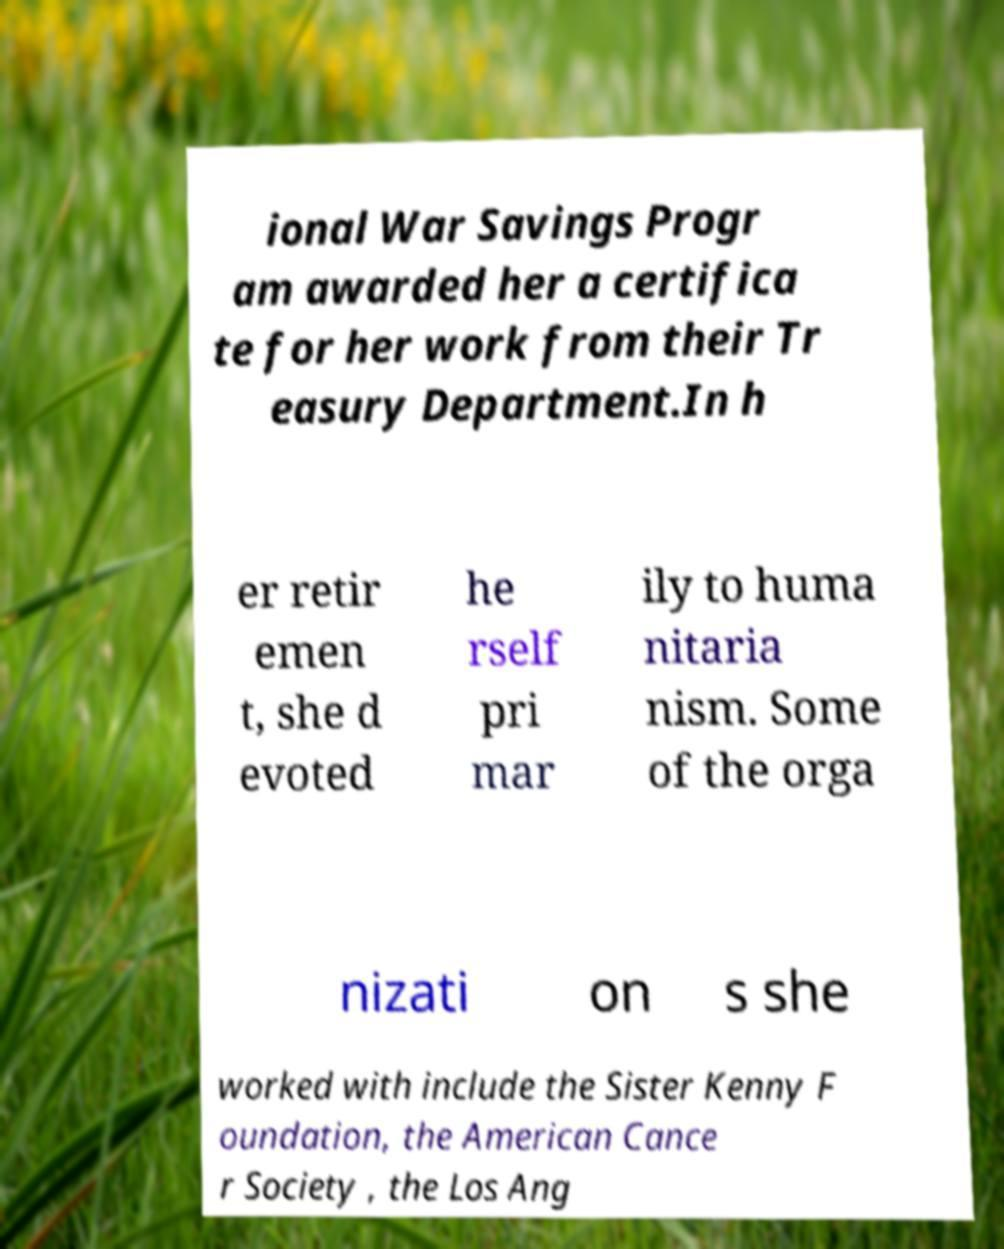I need the written content from this picture converted into text. Can you do that? ional War Savings Progr am awarded her a certifica te for her work from their Tr easury Department.In h er retir emen t, she d evoted he rself pri mar ily to huma nitaria nism. Some of the orga nizati on s she worked with include the Sister Kenny F oundation, the American Cance r Society , the Los Ang 